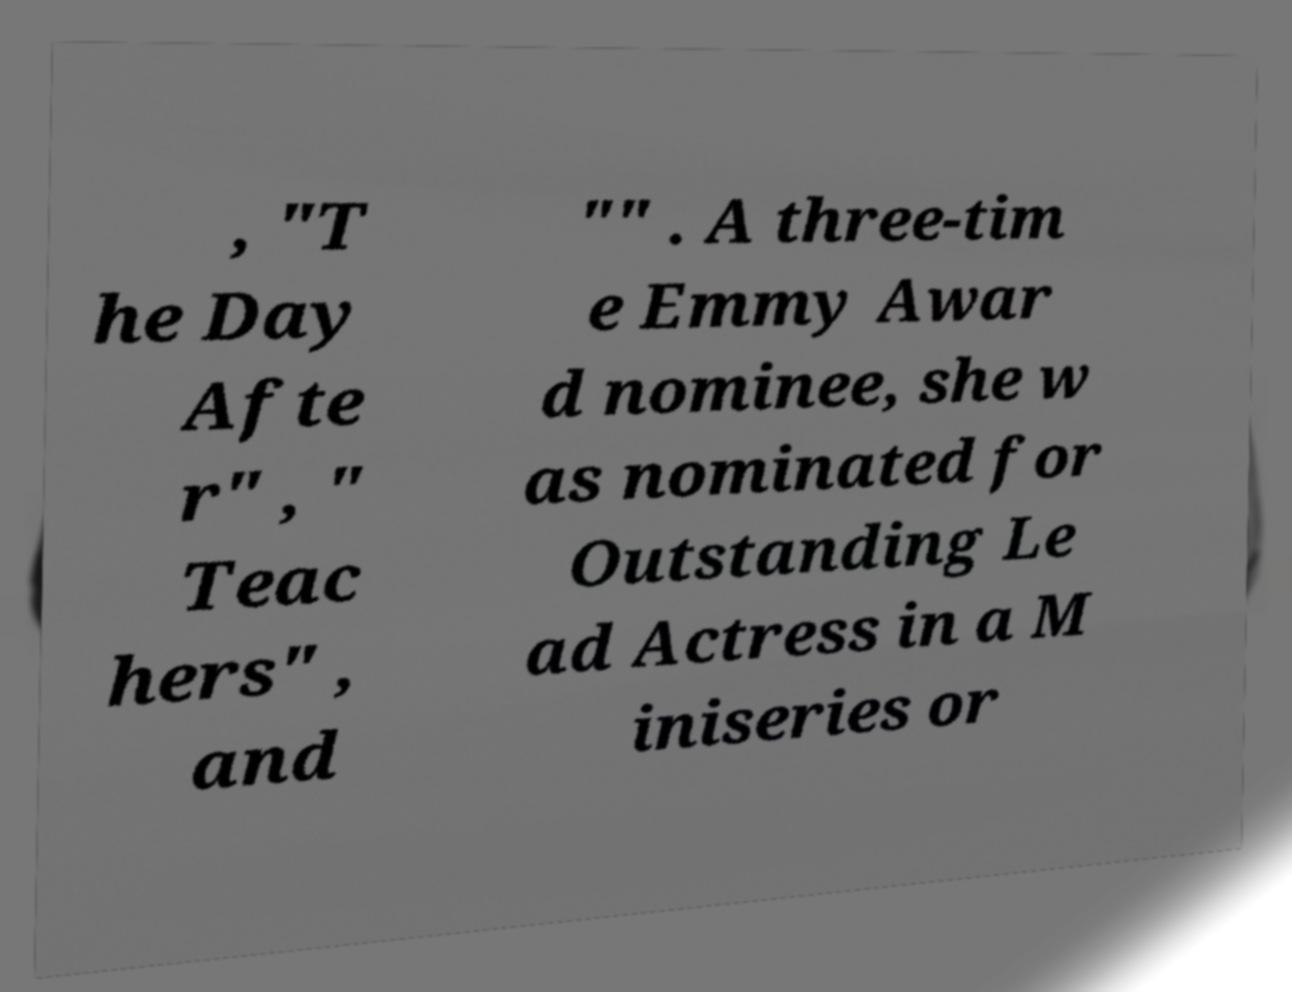Can you accurately transcribe the text from the provided image for me? , "T he Day Afte r" , " Teac hers" , and "" . A three-tim e Emmy Awar d nominee, she w as nominated for Outstanding Le ad Actress in a M iniseries or 